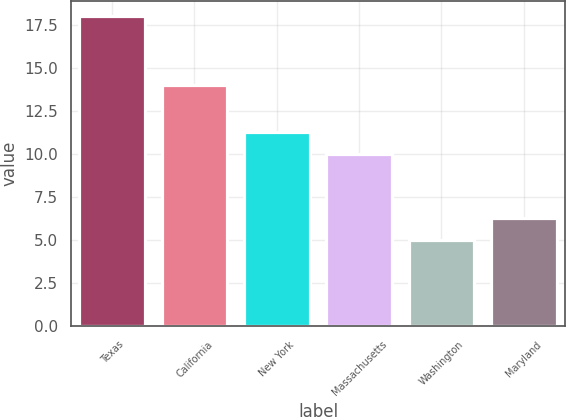Convert chart to OTSL. <chart><loc_0><loc_0><loc_500><loc_500><bar_chart><fcel>Texas<fcel>California<fcel>New York<fcel>Massachusetts<fcel>Washington<fcel>Maryland<nl><fcel>18<fcel>14<fcel>11.3<fcel>10<fcel>5<fcel>6.3<nl></chart> 